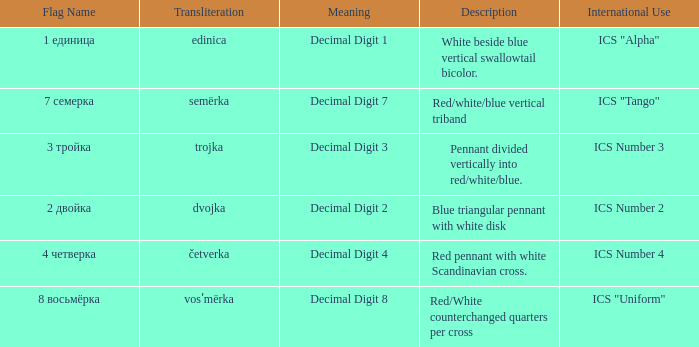What are the meanings of the flag whose name transliterates to dvojka? Decimal Digit 2. 